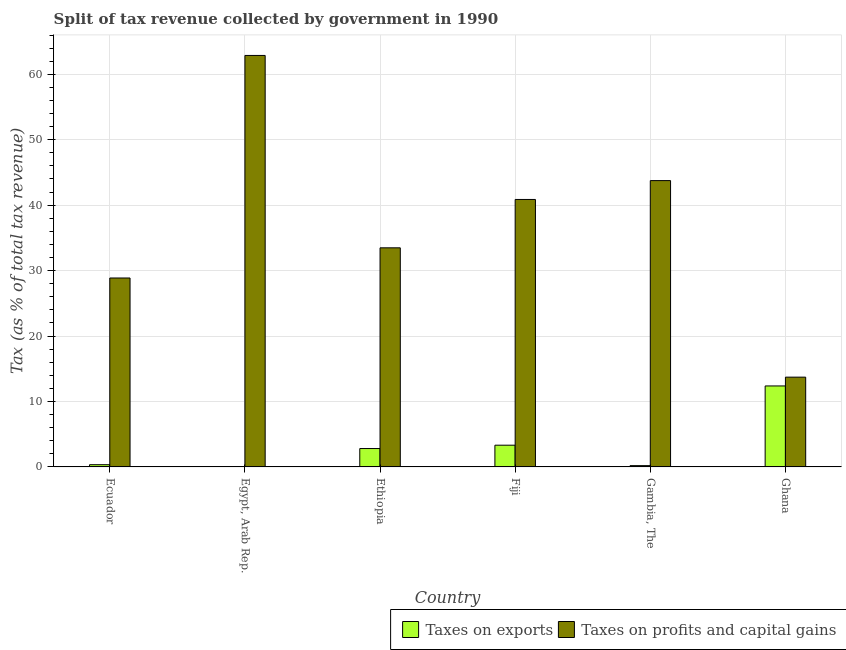How many different coloured bars are there?
Provide a short and direct response. 2. Are the number of bars on each tick of the X-axis equal?
Your answer should be compact. Yes. What is the label of the 4th group of bars from the left?
Ensure brevity in your answer.  Fiji. In how many cases, is the number of bars for a given country not equal to the number of legend labels?
Offer a very short reply. 0. What is the percentage of revenue obtained from taxes on exports in Ghana?
Your response must be concise. 12.37. Across all countries, what is the maximum percentage of revenue obtained from taxes on exports?
Offer a terse response. 12.37. Across all countries, what is the minimum percentage of revenue obtained from taxes on profits and capital gains?
Provide a succinct answer. 13.72. In which country was the percentage of revenue obtained from taxes on profits and capital gains minimum?
Make the answer very short. Ghana. What is the total percentage of revenue obtained from taxes on profits and capital gains in the graph?
Provide a short and direct response. 223.57. What is the difference between the percentage of revenue obtained from taxes on exports in Gambia, The and that in Ghana?
Offer a very short reply. -12.18. What is the difference between the percentage of revenue obtained from taxes on exports in Fiji and the percentage of revenue obtained from taxes on profits and capital gains in Egypt, Arab Rep.?
Offer a terse response. -59.56. What is the average percentage of revenue obtained from taxes on exports per country?
Keep it short and to the point. 3.18. What is the difference between the percentage of revenue obtained from taxes on exports and percentage of revenue obtained from taxes on profits and capital gains in Egypt, Arab Rep.?
Give a very brief answer. -62.86. What is the ratio of the percentage of revenue obtained from taxes on profits and capital gains in Ecuador to that in Ethiopia?
Make the answer very short. 0.86. Is the difference between the percentage of revenue obtained from taxes on exports in Fiji and Gambia, The greater than the difference between the percentage of revenue obtained from taxes on profits and capital gains in Fiji and Gambia, The?
Give a very brief answer. Yes. What is the difference between the highest and the second highest percentage of revenue obtained from taxes on exports?
Give a very brief answer. 9.05. What is the difference between the highest and the lowest percentage of revenue obtained from taxes on profits and capital gains?
Provide a short and direct response. 49.16. Is the sum of the percentage of revenue obtained from taxes on exports in Ethiopia and Gambia, The greater than the maximum percentage of revenue obtained from taxes on profits and capital gains across all countries?
Give a very brief answer. No. What does the 1st bar from the left in Ethiopia represents?
Make the answer very short. Taxes on exports. What does the 1st bar from the right in Egypt, Arab Rep. represents?
Offer a terse response. Taxes on profits and capital gains. Are all the bars in the graph horizontal?
Your answer should be very brief. No. How many countries are there in the graph?
Offer a terse response. 6. Does the graph contain any zero values?
Offer a terse response. No. What is the title of the graph?
Provide a short and direct response. Split of tax revenue collected by government in 1990. What is the label or title of the Y-axis?
Your response must be concise. Tax (as % of total tax revenue). What is the Tax (as % of total tax revenue) in Taxes on exports in Ecuador?
Your response must be concise. 0.34. What is the Tax (as % of total tax revenue) of Taxes on profits and capital gains in Ecuador?
Your answer should be very brief. 28.87. What is the Tax (as % of total tax revenue) in Taxes on exports in Egypt, Arab Rep.?
Offer a terse response. 0.02. What is the Tax (as % of total tax revenue) of Taxes on profits and capital gains in Egypt, Arab Rep.?
Make the answer very short. 62.88. What is the Tax (as % of total tax revenue) of Taxes on exports in Ethiopia?
Your answer should be very brief. 2.81. What is the Tax (as % of total tax revenue) of Taxes on profits and capital gains in Ethiopia?
Make the answer very short. 33.48. What is the Tax (as % of total tax revenue) in Taxes on exports in Fiji?
Provide a short and direct response. 3.32. What is the Tax (as % of total tax revenue) of Taxes on profits and capital gains in Fiji?
Give a very brief answer. 40.87. What is the Tax (as % of total tax revenue) of Taxes on exports in Gambia, The?
Offer a very short reply. 0.2. What is the Tax (as % of total tax revenue) in Taxes on profits and capital gains in Gambia, The?
Provide a succinct answer. 43.75. What is the Tax (as % of total tax revenue) of Taxes on exports in Ghana?
Provide a succinct answer. 12.37. What is the Tax (as % of total tax revenue) of Taxes on profits and capital gains in Ghana?
Provide a succinct answer. 13.72. Across all countries, what is the maximum Tax (as % of total tax revenue) of Taxes on exports?
Make the answer very short. 12.37. Across all countries, what is the maximum Tax (as % of total tax revenue) in Taxes on profits and capital gains?
Offer a terse response. 62.88. Across all countries, what is the minimum Tax (as % of total tax revenue) in Taxes on exports?
Give a very brief answer. 0.02. Across all countries, what is the minimum Tax (as % of total tax revenue) of Taxes on profits and capital gains?
Keep it short and to the point. 13.72. What is the total Tax (as % of total tax revenue) of Taxes on exports in the graph?
Ensure brevity in your answer.  19.06. What is the total Tax (as % of total tax revenue) in Taxes on profits and capital gains in the graph?
Make the answer very short. 223.57. What is the difference between the Tax (as % of total tax revenue) of Taxes on exports in Ecuador and that in Egypt, Arab Rep.?
Ensure brevity in your answer.  0.33. What is the difference between the Tax (as % of total tax revenue) in Taxes on profits and capital gains in Ecuador and that in Egypt, Arab Rep.?
Ensure brevity in your answer.  -34.01. What is the difference between the Tax (as % of total tax revenue) in Taxes on exports in Ecuador and that in Ethiopia?
Your response must be concise. -2.47. What is the difference between the Tax (as % of total tax revenue) of Taxes on profits and capital gains in Ecuador and that in Ethiopia?
Ensure brevity in your answer.  -4.61. What is the difference between the Tax (as % of total tax revenue) of Taxes on exports in Ecuador and that in Fiji?
Offer a terse response. -2.98. What is the difference between the Tax (as % of total tax revenue) in Taxes on profits and capital gains in Ecuador and that in Fiji?
Offer a very short reply. -12. What is the difference between the Tax (as % of total tax revenue) in Taxes on exports in Ecuador and that in Gambia, The?
Keep it short and to the point. 0.14. What is the difference between the Tax (as % of total tax revenue) of Taxes on profits and capital gains in Ecuador and that in Gambia, The?
Give a very brief answer. -14.88. What is the difference between the Tax (as % of total tax revenue) of Taxes on exports in Ecuador and that in Ghana?
Offer a very short reply. -12.03. What is the difference between the Tax (as % of total tax revenue) in Taxes on profits and capital gains in Ecuador and that in Ghana?
Offer a terse response. 15.15. What is the difference between the Tax (as % of total tax revenue) of Taxes on exports in Egypt, Arab Rep. and that in Ethiopia?
Give a very brief answer. -2.79. What is the difference between the Tax (as % of total tax revenue) in Taxes on profits and capital gains in Egypt, Arab Rep. and that in Ethiopia?
Your response must be concise. 29.4. What is the difference between the Tax (as % of total tax revenue) of Taxes on exports in Egypt, Arab Rep. and that in Fiji?
Provide a short and direct response. -3.3. What is the difference between the Tax (as % of total tax revenue) of Taxes on profits and capital gains in Egypt, Arab Rep. and that in Fiji?
Your answer should be compact. 22. What is the difference between the Tax (as % of total tax revenue) in Taxes on exports in Egypt, Arab Rep. and that in Gambia, The?
Your answer should be compact. -0.18. What is the difference between the Tax (as % of total tax revenue) of Taxes on profits and capital gains in Egypt, Arab Rep. and that in Gambia, The?
Your response must be concise. 19.13. What is the difference between the Tax (as % of total tax revenue) in Taxes on exports in Egypt, Arab Rep. and that in Ghana?
Keep it short and to the point. -12.36. What is the difference between the Tax (as % of total tax revenue) of Taxes on profits and capital gains in Egypt, Arab Rep. and that in Ghana?
Provide a succinct answer. 49.16. What is the difference between the Tax (as % of total tax revenue) of Taxes on exports in Ethiopia and that in Fiji?
Offer a very short reply. -0.51. What is the difference between the Tax (as % of total tax revenue) in Taxes on profits and capital gains in Ethiopia and that in Fiji?
Offer a terse response. -7.39. What is the difference between the Tax (as % of total tax revenue) in Taxes on exports in Ethiopia and that in Gambia, The?
Give a very brief answer. 2.61. What is the difference between the Tax (as % of total tax revenue) of Taxes on profits and capital gains in Ethiopia and that in Gambia, The?
Your answer should be compact. -10.27. What is the difference between the Tax (as % of total tax revenue) in Taxes on exports in Ethiopia and that in Ghana?
Your answer should be compact. -9.56. What is the difference between the Tax (as % of total tax revenue) of Taxes on profits and capital gains in Ethiopia and that in Ghana?
Provide a succinct answer. 19.76. What is the difference between the Tax (as % of total tax revenue) of Taxes on exports in Fiji and that in Gambia, The?
Ensure brevity in your answer.  3.12. What is the difference between the Tax (as % of total tax revenue) in Taxes on profits and capital gains in Fiji and that in Gambia, The?
Keep it short and to the point. -2.88. What is the difference between the Tax (as % of total tax revenue) of Taxes on exports in Fiji and that in Ghana?
Your answer should be very brief. -9.05. What is the difference between the Tax (as % of total tax revenue) in Taxes on profits and capital gains in Fiji and that in Ghana?
Give a very brief answer. 27.15. What is the difference between the Tax (as % of total tax revenue) in Taxes on exports in Gambia, The and that in Ghana?
Ensure brevity in your answer.  -12.18. What is the difference between the Tax (as % of total tax revenue) of Taxes on profits and capital gains in Gambia, The and that in Ghana?
Your answer should be very brief. 30.03. What is the difference between the Tax (as % of total tax revenue) of Taxes on exports in Ecuador and the Tax (as % of total tax revenue) of Taxes on profits and capital gains in Egypt, Arab Rep.?
Offer a terse response. -62.53. What is the difference between the Tax (as % of total tax revenue) in Taxes on exports in Ecuador and the Tax (as % of total tax revenue) in Taxes on profits and capital gains in Ethiopia?
Provide a succinct answer. -33.14. What is the difference between the Tax (as % of total tax revenue) of Taxes on exports in Ecuador and the Tax (as % of total tax revenue) of Taxes on profits and capital gains in Fiji?
Offer a terse response. -40.53. What is the difference between the Tax (as % of total tax revenue) in Taxes on exports in Ecuador and the Tax (as % of total tax revenue) in Taxes on profits and capital gains in Gambia, The?
Offer a very short reply. -43.41. What is the difference between the Tax (as % of total tax revenue) in Taxes on exports in Ecuador and the Tax (as % of total tax revenue) in Taxes on profits and capital gains in Ghana?
Your response must be concise. -13.38. What is the difference between the Tax (as % of total tax revenue) of Taxes on exports in Egypt, Arab Rep. and the Tax (as % of total tax revenue) of Taxes on profits and capital gains in Ethiopia?
Make the answer very short. -33.46. What is the difference between the Tax (as % of total tax revenue) in Taxes on exports in Egypt, Arab Rep. and the Tax (as % of total tax revenue) in Taxes on profits and capital gains in Fiji?
Your answer should be very brief. -40.86. What is the difference between the Tax (as % of total tax revenue) in Taxes on exports in Egypt, Arab Rep. and the Tax (as % of total tax revenue) in Taxes on profits and capital gains in Gambia, The?
Make the answer very short. -43.74. What is the difference between the Tax (as % of total tax revenue) of Taxes on exports in Egypt, Arab Rep. and the Tax (as % of total tax revenue) of Taxes on profits and capital gains in Ghana?
Your answer should be very brief. -13.7. What is the difference between the Tax (as % of total tax revenue) of Taxes on exports in Ethiopia and the Tax (as % of total tax revenue) of Taxes on profits and capital gains in Fiji?
Offer a terse response. -38.06. What is the difference between the Tax (as % of total tax revenue) in Taxes on exports in Ethiopia and the Tax (as % of total tax revenue) in Taxes on profits and capital gains in Gambia, The?
Ensure brevity in your answer.  -40.94. What is the difference between the Tax (as % of total tax revenue) of Taxes on exports in Ethiopia and the Tax (as % of total tax revenue) of Taxes on profits and capital gains in Ghana?
Offer a very short reply. -10.91. What is the difference between the Tax (as % of total tax revenue) in Taxes on exports in Fiji and the Tax (as % of total tax revenue) in Taxes on profits and capital gains in Gambia, The?
Your answer should be compact. -40.43. What is the difference between the Tax (as % of total tax revenue) of Taxes on exports in Fiji and the Tax (as % of total tax revenue) of Taxes on profits and capital gains in Ghana?
Keep it short and to the point. -10.4. What is the difference between the Tax (as % of total tax revenue) in Taxes on exports in Gambia, The and the Tax (as % of total tax revenue) in Taxes on profits and capital gains in Ghana?
Make the answer very short. -13.52. What is the average Tax (as % of total tax revenue) of Taxes on exports per country?
Ensure brevity in your answer.  3.18. What is the average Tax (as % of total tax revenue) of Taxes on profits and capital gains per country?
Offer a very short reply. 37.26. What is the difference between the Tax (as % of total tax revenue) in Taxes on exports and Tax (as % of total tax revenue) in Taxes on profits and capital gains in Ecuador?
Provide a succinct answer. -28.53. What is the difference between the Tax (as % of total tax revenue) of Taxes on exports and Tax (as % of total tax revenue) of Taxes on profits and capital gains in Egypt, Arab Rep.?
Your answer should be compact. -62.86. What is the difference between the Tax (as % of total tax revenue) of Taxes on exports and Tax (as % of total tax revenue) of Taxes on profits and capital gains in Ethiopia?
Your response must be concise. -30.67. What is the difference between the Tax (as % of total tax revenue) of Taxes on exports and Tax (as % of total tax revenue) of Taxes on profits and capital gains in Fiji?
Give a very brief answer. -37.55. What is the difference between the Tax (as % of total tax revenue) in Taxes on exports and Tax (as % of total tax revenue) in Taxes on profits and capital gains in Gambia, The?
Offer a terse response. -43.55. What is the difference between the Tax (as % of total tax revenue) of Taxes on exports and Tax (as % of total tax revenue) of Taxes on profits and capital gains in Ghana?
Your answer should be compact. -1.35. What is the ratio of the Tax (as % of total tax revenue) of Taxes on exports in Ecuador to that in Egypt, Arab Rep.?
Provide a succinct answer. 21.71. What is the ratio of the Tax (as % of total tax revenue) in Taxes on profits and capital gains in Ecuador to that in Egypt, Arab Rep.?
Offer a terse response. 0.46. What is the ratio of the Tax (as % of total tax revenue) in Taxes on exports in Ecuador to that in Ethiopia?
Provide a short and direct response. 0.12. What is the ratio of the Tax (as % of total tax revenue) in Taxes on profits and capital gains in Ecuador to that in Ethiopia?
Provide a short and direct response. 0.86. What is the ratio of the Tax (as % of total tax revenue) of Taxes on exports in Ecuador to that in Fiji?
Ensure brevity in your answer.  0.1. What is the ratio of the Tax (as % of total tax revenue) of Taxes on profits and capital gains in Ecuador to that in Fiji?
Ensure brevity in your answer.  0.71. What is the ratio of the Tax (as % of total tax revenue) in Taxes on exports in Ecuador to that in Gambia, The?
Offer a terse response. 1.73. What is the ratio of the Tax (as % of total tax revenue) in Taxes on profits and capital gains in Ecuador to that in Gambia, The?
Give a very brief answer. 0.66. What is the ratio of the Tax (as % of total tax revenue) in Taxes on exports in Ecuador to that in Ghana?
Offer a very short reply. 0.03. What is the ratio of the Tax (as % of total tax revenue) in Taxes on profits and capital gains in Ecuador to that in Ghana?
Offer a very short reply. 2.1. What is the ratio of the Tax (as % of total tax revenue) in Taxes on exports in Egypt, Arab Rep. to that in Ethiopia?
Ensure brevity in your answer.  0.01. What is the ratio of the Tax (as % of total tax revenue) of Taxes on profits and capital gains in Egypt, Arab Rep. to that in Ethiopia?
Your answer should be compact. 1.88. What is the ratio of the Tax (as % of total tax revenue) in Taxes on exports in Egypt, Arab Rep. to that in Fiji?
Your answer should be compact. 0. What is the ratio of the Tax (as % of total tax revenue) in Taxes on profits and capital gains in Egypt, Arab Rep. to that in Fiji?
Make the answer very short. 1.54. What is the ratio of the Tax (as % of total tax revenue) in Taxes on exports in Egypt, Arab Rep. to that in Gambia, The?
Your response must be concise. 0.08. What is the ratio of the Tax (as % of total tax revenue) of Taxes on profits and capital gains in Egypt, Arab Rep. to that in Gambia, The?
Your answer should be very brief. 1.44. What is the ratio of the Tax (as % of total tax revenue) in Taxes on exports in Egypt, Arab Rep. to that in Ghana?
Offer a terse response. 0. What is the ratio of the Tax (as % of total tax revenue) in Taxes on profits and capital gains in Egypt, Arab Rep. to that in Ghana?
Offer a terse response. 4.58. What is the ratio of the Tax (as % of total tax revenue) in Taxes on exports in Ethiopia to that in Fiji?
Your response must be concise. 0.85. What is the ratio of the Tax (as % of total tax revenue) of Taxes on profits and capital gains in Ethiopia to that in Fiji?
Make the answer very short. 0.82. What is the ratio of the Tax (as % of total tax revenue) of Taxes on exports in Ethiopia to that in Gambia, The?
Your response must be concise. 14.2. What is the ratio of the Tax (as % of total tax revenue) in Taxes on profits and capital gains in Ethiopia to that in Gambia, The?
Keep it short and to the point. 0.77. What is the ratio of the Tax (as % of total tax revenue) of Taxes on exports in Ethiopia to that in Ghana?
Provide a short and direct response. 0.23. What is the ratio of the Tax (as % of total tax revenue) in Taxes on profits and capital gains in Ethiopia to that in Ghana?
Provide a succinct answer. 2.44. What is the ratio of the Tax (as % of total tax revenue) of Taxes on exports in Fiji to that in Gambia, The?
Give a very brief answer. 16.78. What is the ratio of the Tax (as % of total tax revenue) of Taxes on profits and capital gains in Fiji to that in Gambia, The?
Offer a terse response. 0.93. What is the ratio of the Tax (as % of total tax revenue) of Taxes on exports in Fiji to that in Ghana?
Provide a succinct answer. 0.27. What is the ratio of the Tax (as % of total tax revenue) of Taxes on profits and capital gains in Fiji to that in Ghana?
Make the answer very short. 2.98. What is the ratio of the Tax (as % of total tax revenue) of Taxes on exports in Gambia, The to that in Ghana?
Provide a succinct answer. 0.02. What is the ratio of the Tax (as % of total tax revenue) in Taxes on profits and capital gains in Gambia, The to that in Ghana?
Provide a succinct answer. 3.19. What is the difference between the highest and the second highest Tax (as % of total tax revenue) in Taxes on exports?
Your response must be concise. 9.05. What is the difference between the highest and the second highest Tax (as % of total tax revenue) in Taxes on profits and capital gains?
Your answer should be compact. 19.13. What is the difference between the highest and the lowest Tax (as % of total tax revenue) in Taxes on exports?
Give a very brief answer. 12.36. What is the difference between the highest and the lowest Tax (as % of total tax revenue) of Taxes on profits and capital gains?
Provide a succinct answer. 49.16. 